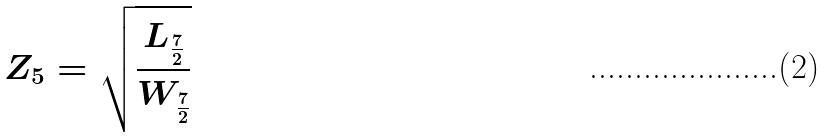<formula> <loc_0><loc_0><loc_500><loc_500>Z _ { 5 } = \sqrt { \frac { L _ { \frac { 7 } { 2 } } } { W _ { \frac { 7 } { 2 } } } }</formula> 